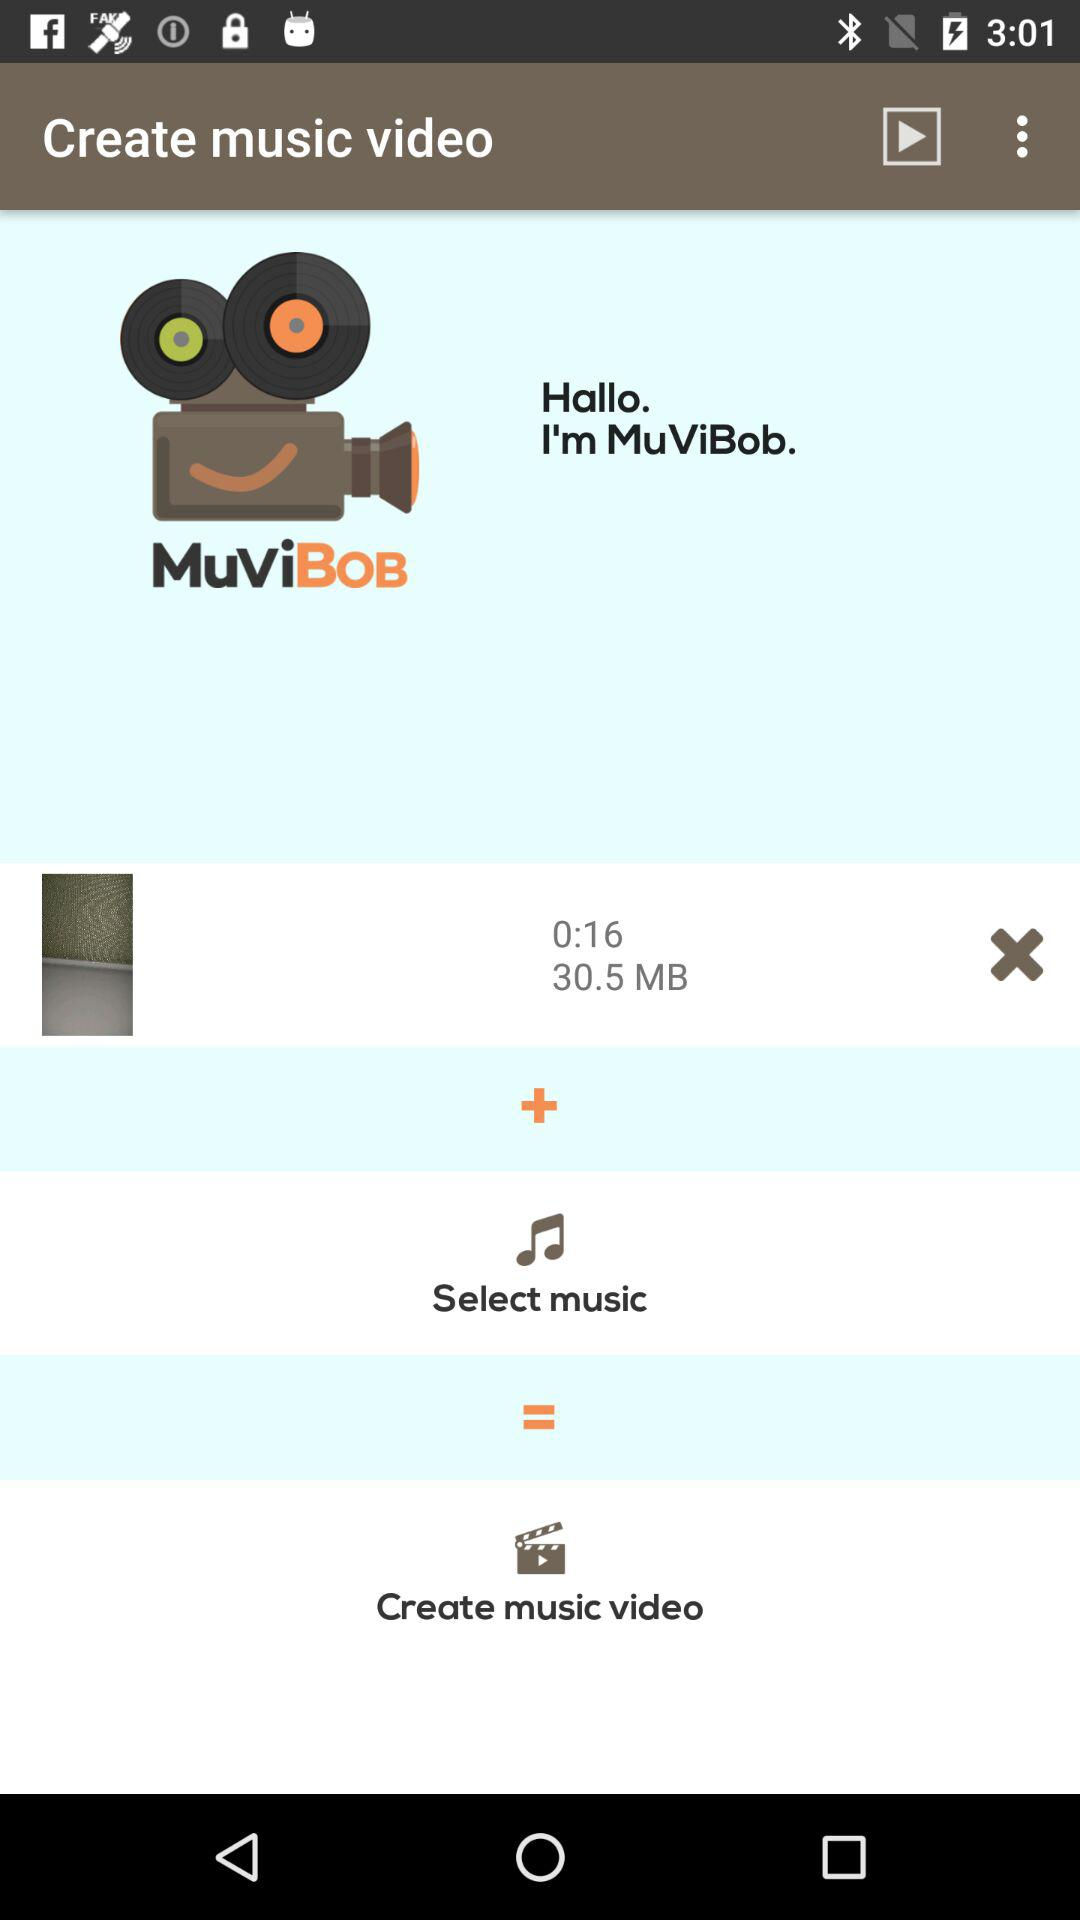What is the application name? The application name is "MuViBob". 